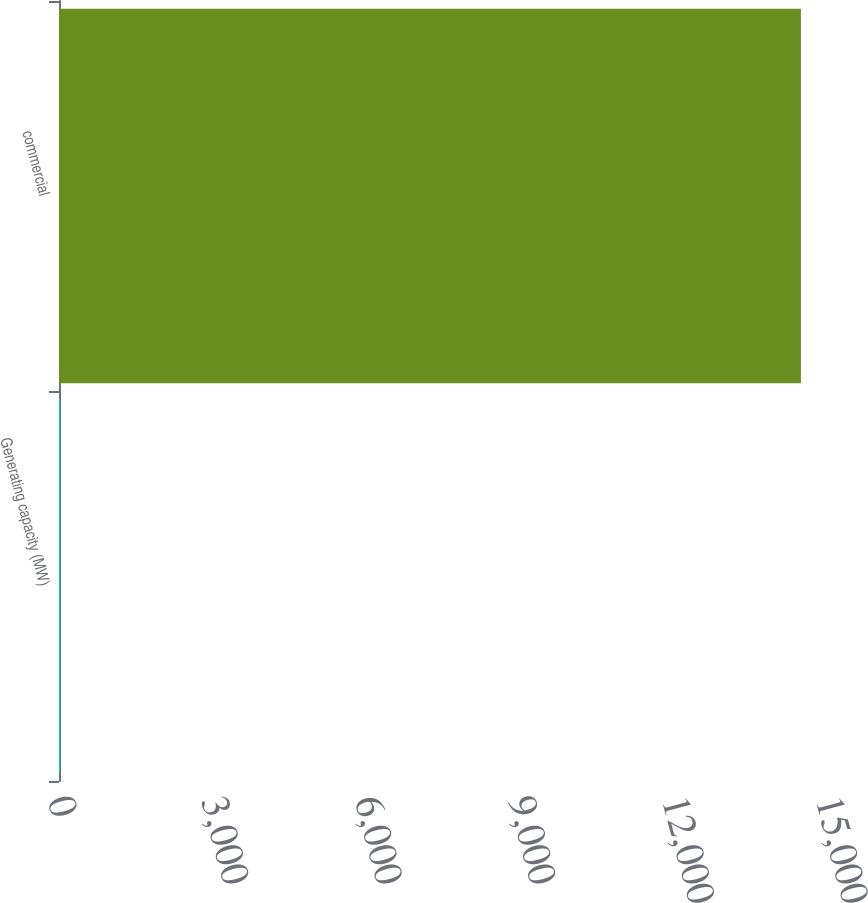Convert chart. <chart><loc_0><loc_0><loc_500><loc_500><bar_chart><fcel>Generating capacity (MW)<fcel>commercial<nl><fcel>21<fcel>14491<nl></chart> 